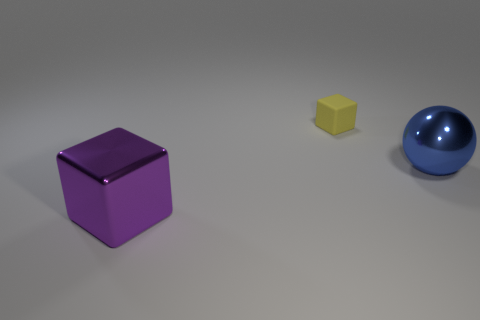Add 3 small yellow metal balls. How many objects exist? 6 Subtract 0 green cylinders. How many objects are left? 3 Subtract all cubes. How many objects are left? 1 Subtract all brown balls. Subtract all blue cylinders. How many balls are left? 1 Subtract all tiny blocks. Subtract all tiny yellow matte things. How many objects are left? 1 Add 3 small things. How many small things are left? 4 Add 3 blue objects. How many blue objects exist? 4 